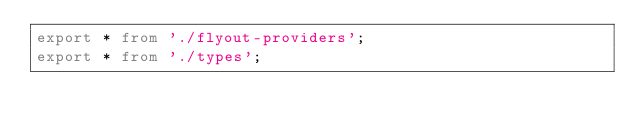Convert code to text. <code><loc_0><loc_0><loc_500><loc_500><_TypeScript_>export * from './flyout-providers';
export * from './types';
</code> 